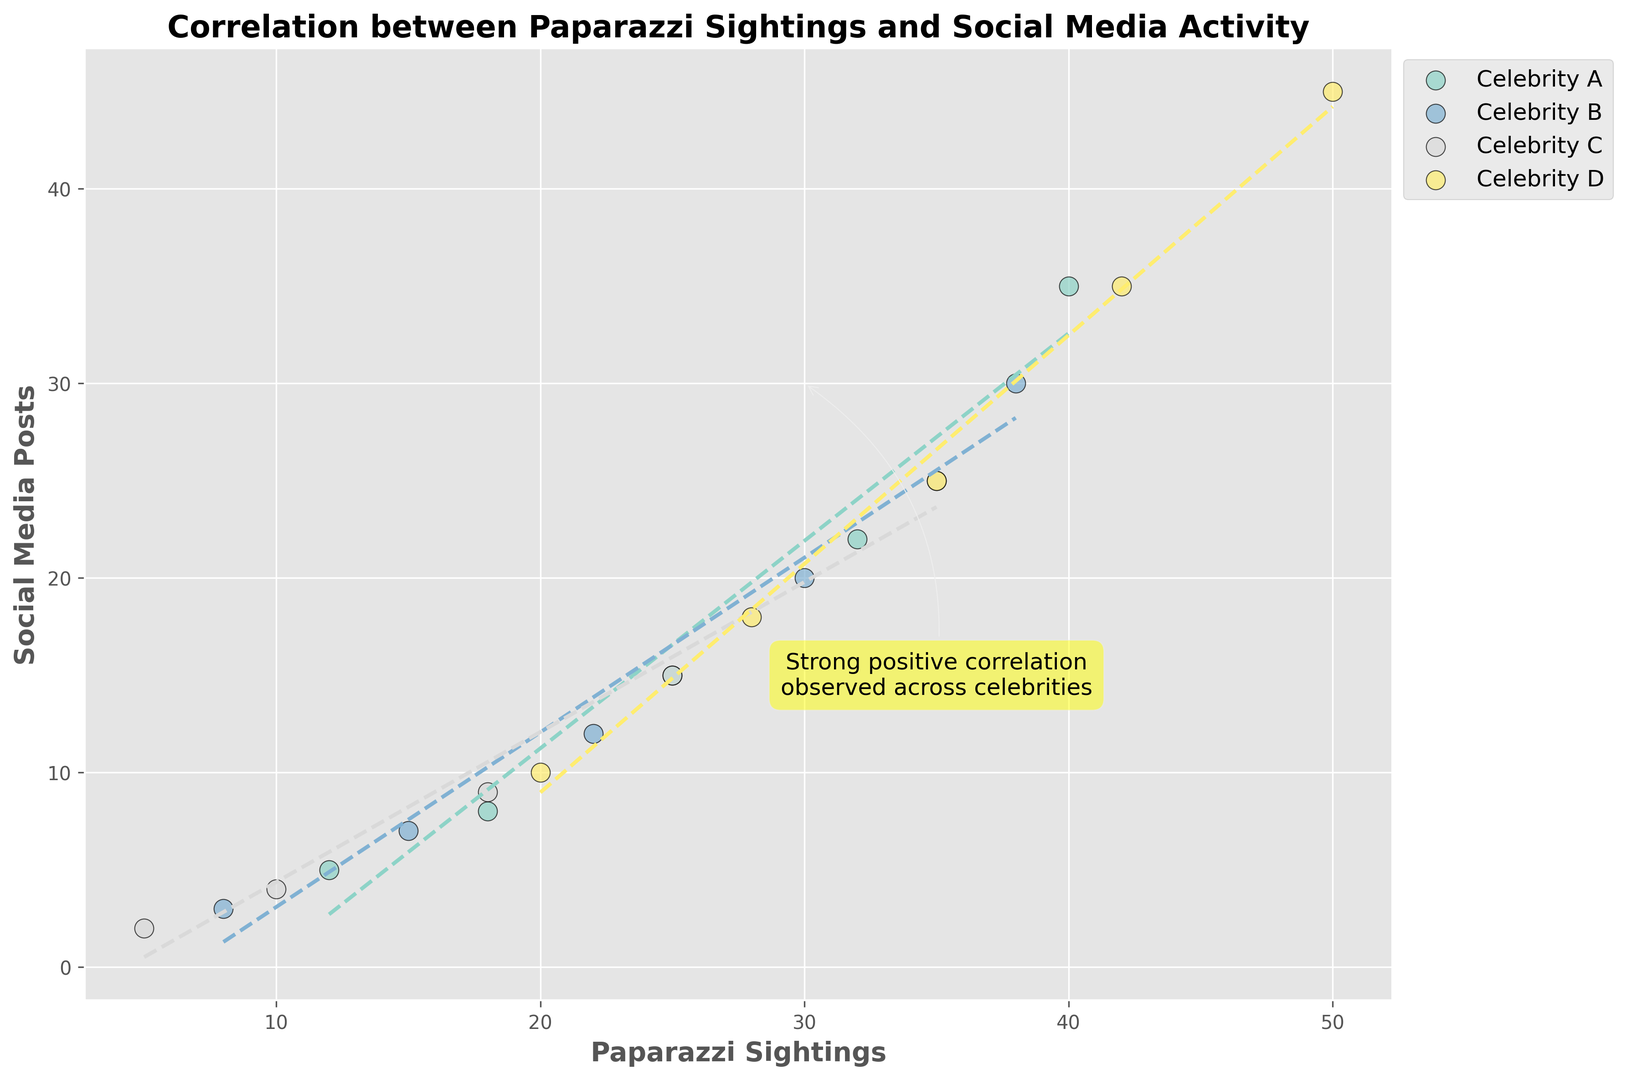What's the trend observed in the figure between paparazzi sightings and social media posts? The figure shows a strong positive correlation between paparazzi sightings and social media posts as indicated by the text annotation "Strong positive correlation observed across celebrities" and the upward sloping dashed lines for each celebrity.
Answer: Strong positive correlation Which celebrity has the highest number of paparazzi sightings and social media posts? Celebrity D has the highest number of paparazzi sightings and social media posts, as seen at the top-right end of the plot, reaching up to 50 sightings and 45 posts.
Answer: Celebrity D How does the trend between paparazzi sightings and social media posts for Celebrity A compare to Celebrity C? Both celebrities show a positive correlation, but Celebrity A seems to have a steeper trend line compared to Celebrity C, implying that for Celebrity A, a higher increase in paparazzi sightings leads to a higher increase in social media posts compared to Celebrity C.
Answer: Celebrity A has a steeper trend What is the total number of paparazzi sightings for Celebrities A and B combined at their highest recorded points? At their highest recorded points, Celebrity A has 40 sightings and Celebrity B has 38 sightings. Adding these together, 40 + 38 = 78.
Answer: 78 Which celebrity has the highest social media activity given a mid-range paparazzi sighting value of 25? For 25 paparazzi sightings, comparing the points on the scatter plot, Celebrity C has 15 social media posts, which is more than other celebrities at the same paparazzi sighting value.
Answer: Celebrity C What can be inferred about the average paparazzi sightings for Celebrity B compared to Celebrity C? Celebrity B's data points average around higher paparazzi sightings values (around 18-38), whereas Celebrity C’s data points average around lower paparazzi sightings values (around 10-35). This can be visualized since their scatter points for B are generally to the right of those for C.
Answer: Celebrity B has higher average paparazzi sightings How do the ranges of social media posts differ between Celebrities A and D? Celebrity A has social media posts ranging from 5 to 35, while Celebrity D has posts ranging from 10 to 45. This is observed by looking at the vertical position (Y-axis) of the scatter points for both celebrities.
Answer: Celebrity D has a wider range Compare the linear trend lines' intercepts of Celebrity A and Celebrity B. Which one is higher? By observing the starting point of the dashed trend lines, Celebrity A’s trend line starts closer to the Y-axis compared to Celebrity B's line, indicating a higher Y-intercept for Celebrity A.
Answer: Celebrity A 